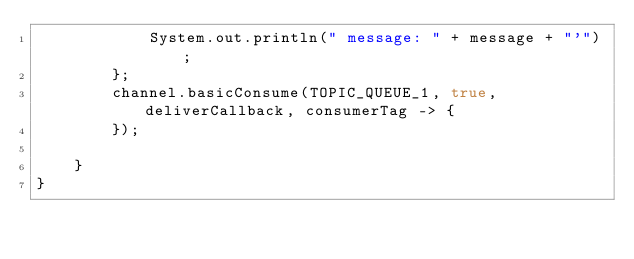Convert code to text. <code><loc_0><loc_0><loc_500><loc_500><_Java_>            System.out.println(" message: " + message + "'");
        };
        channel.basicConsume(TOPIC_QUEUE_1, true, deliverCallback, consumerTag -> {
        });

    }
}
</code> 